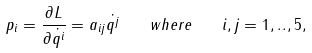<formula> <loc_0><loc_0><loc_500><loc_500>p _ { i } = \frac { \partial L } { \partial \dot { q ^ { i } } } = a _ { i j } \dot { q ^ { j } } \quad w h e r e \quad i , j = 1 , . . , 5 ,</formula> 